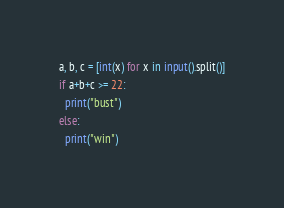Convert code to text. <code><loc_0><loc_0><loc_500><loc_500><_Python_>a, b, c = [int(x) for x in input().split()]
if a+b+c >= 22:
  print("bust")
else:
  print("win")</code> 